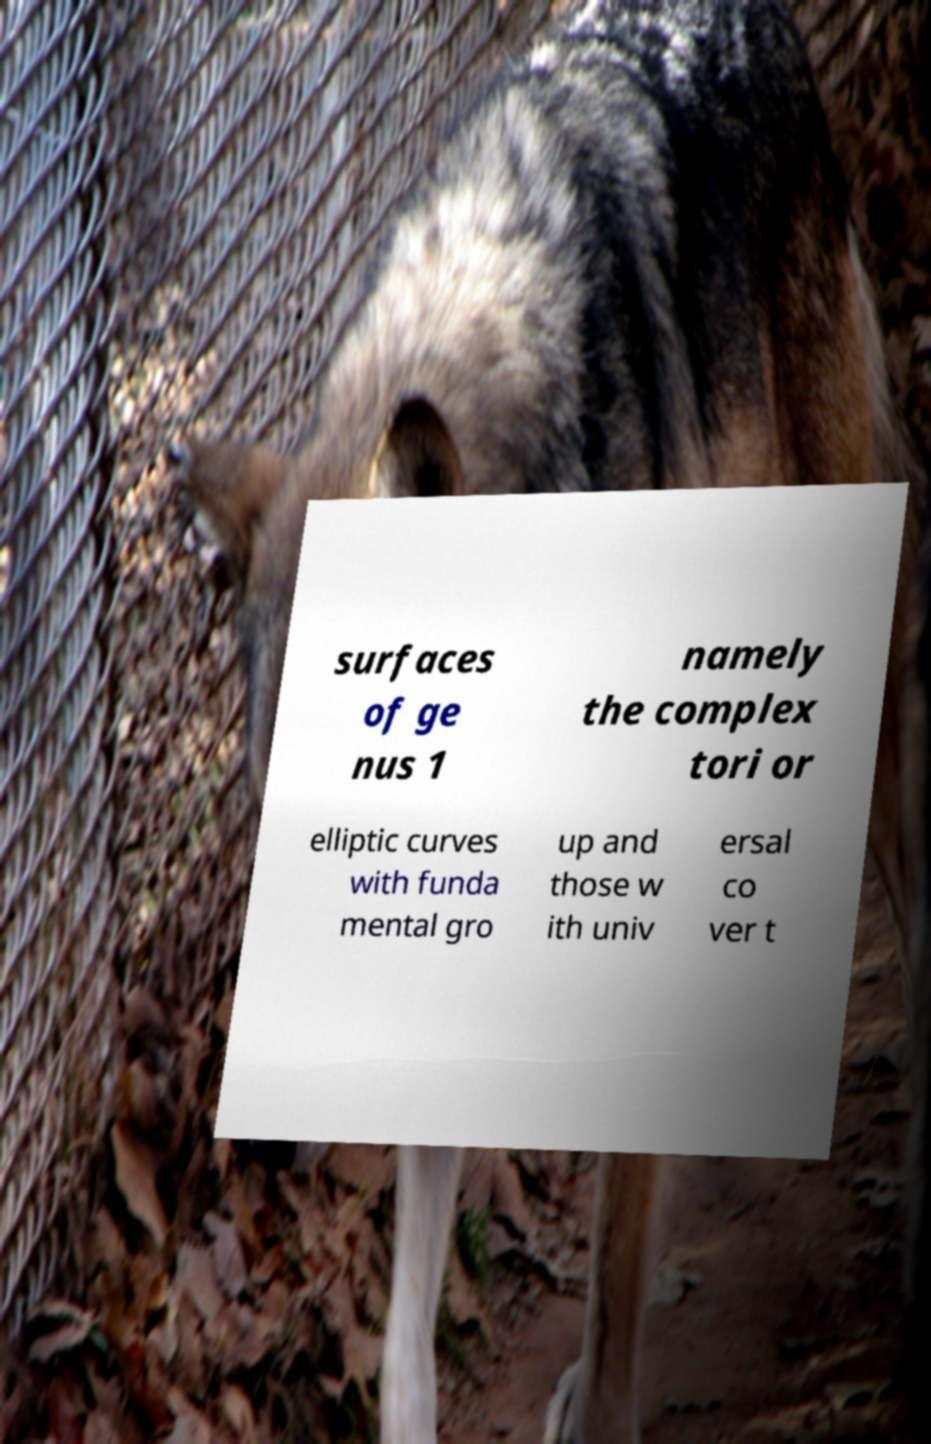Please identify and transcribe the text found in this image. surfaces of ge nus 1 namely the complex tori or elliptic curves with funda mental gro up and those w ith univ ersal co ver t 